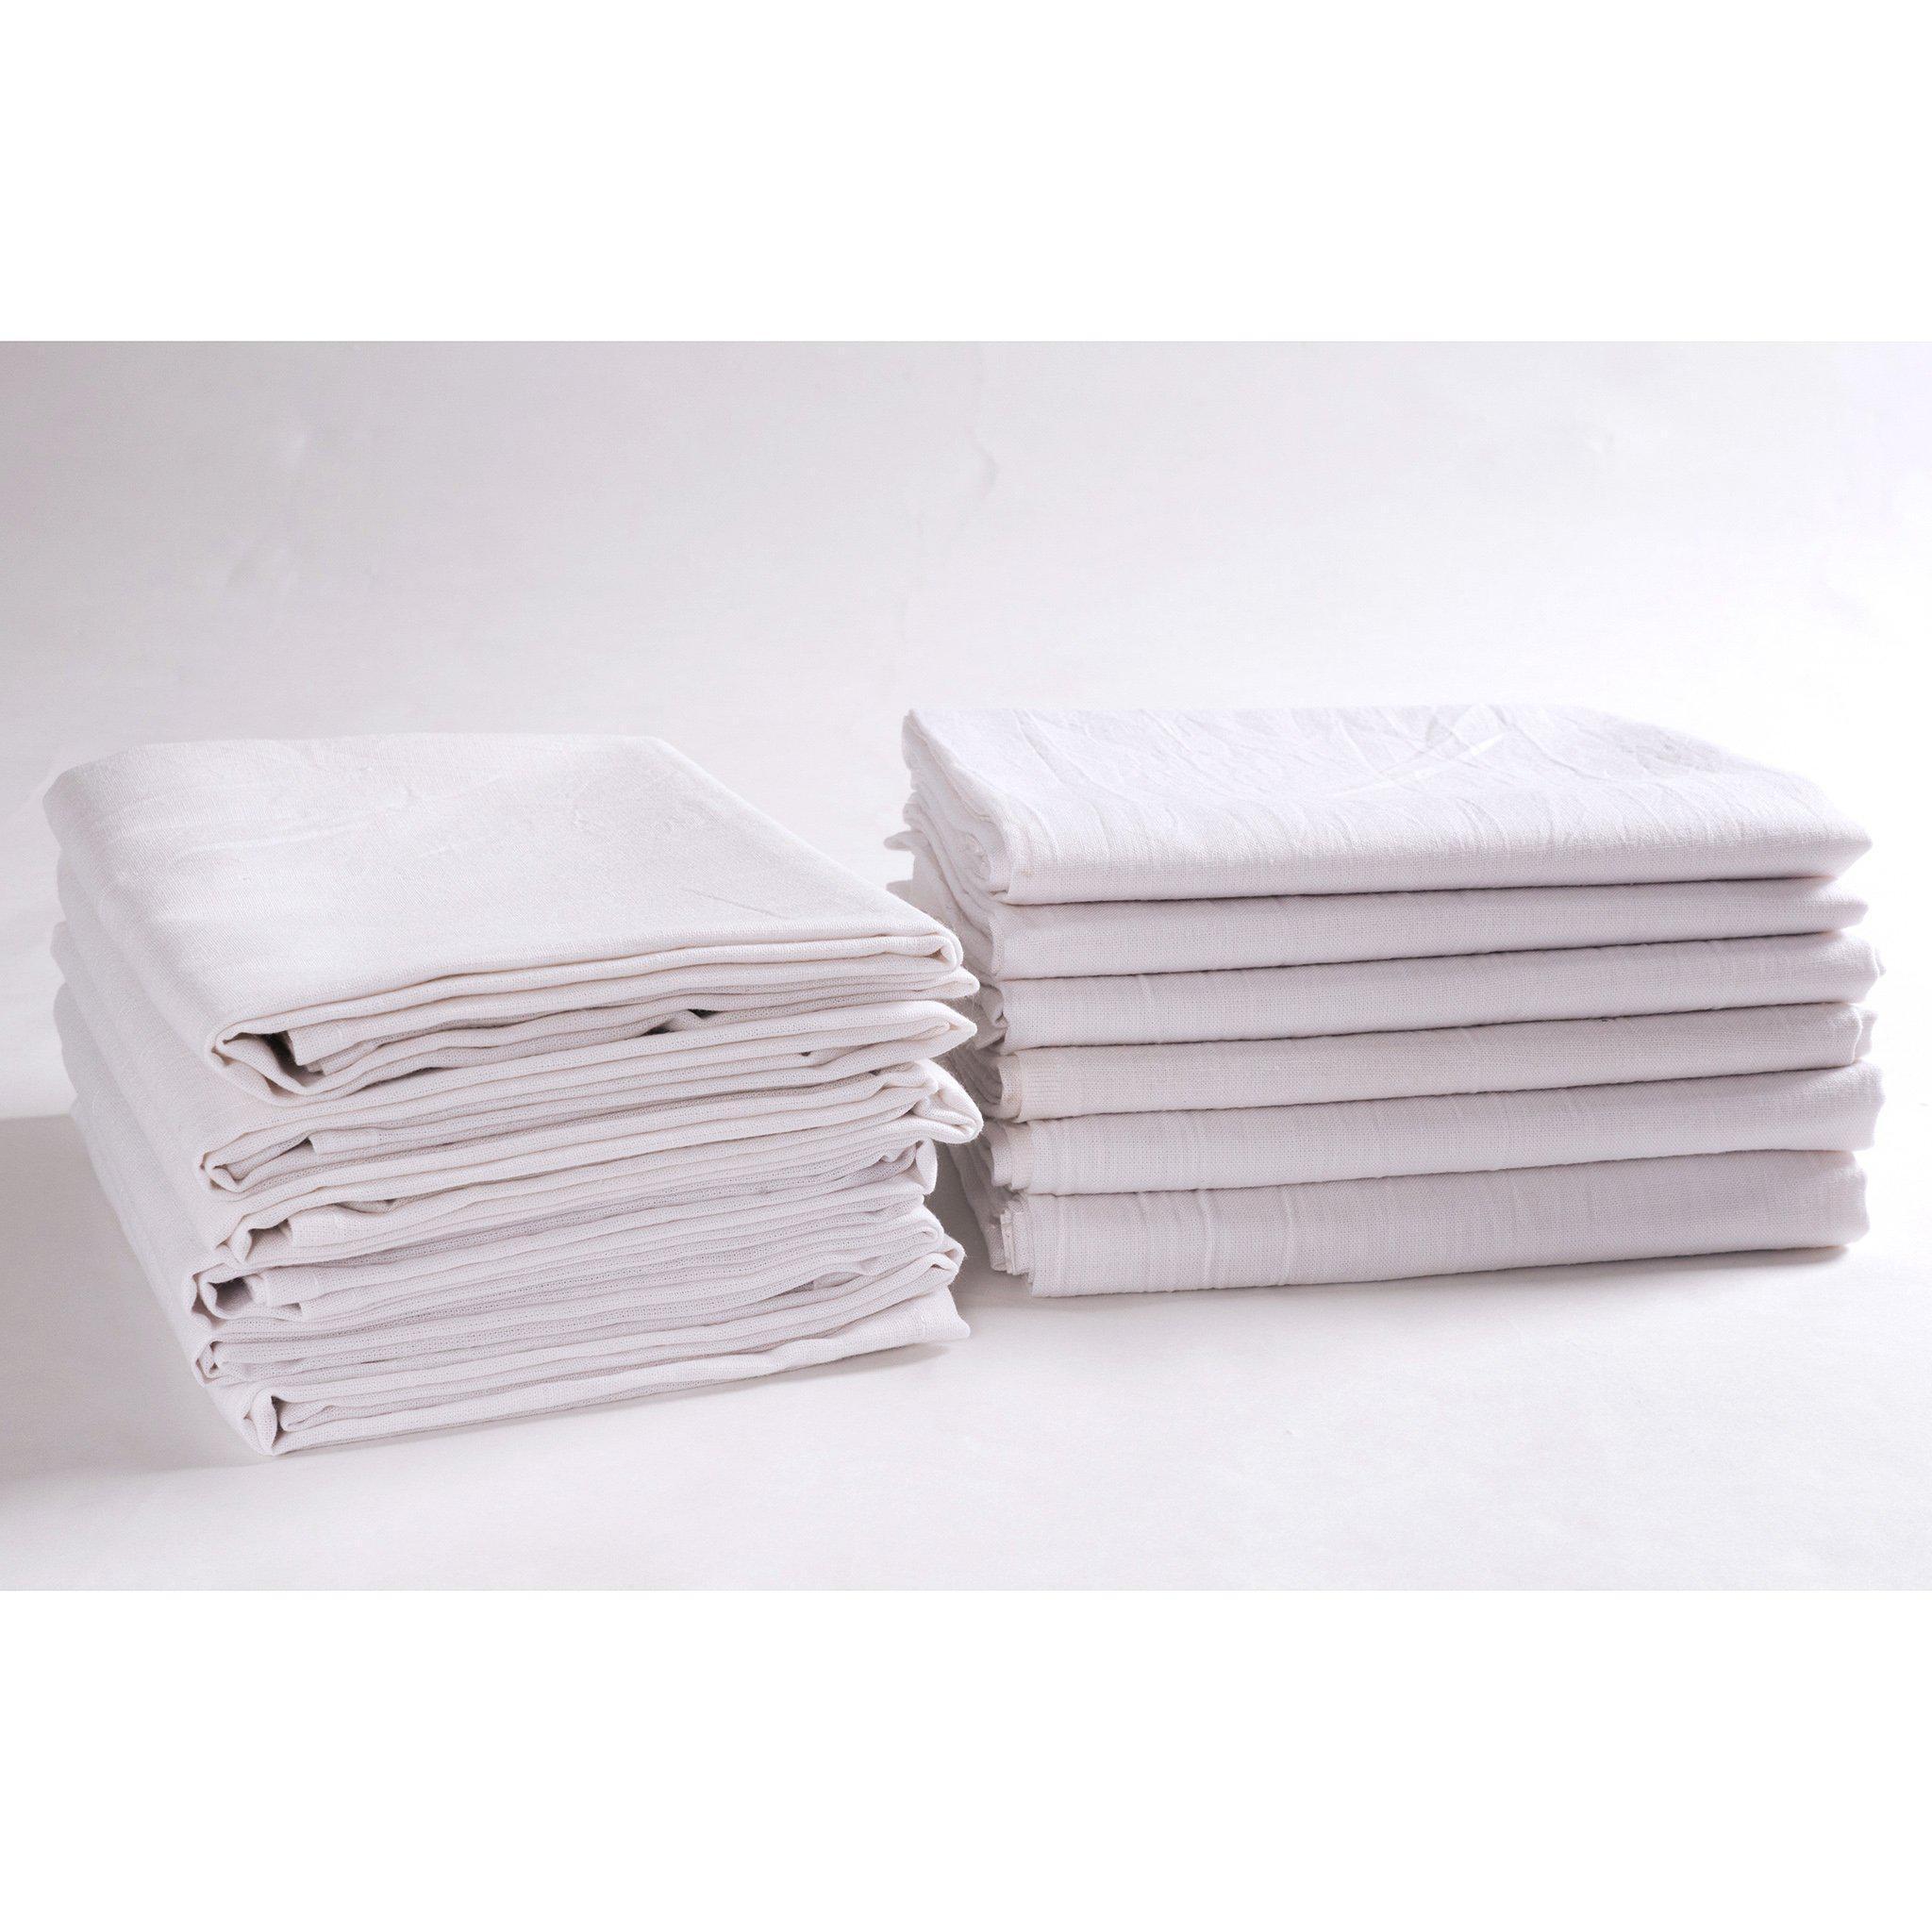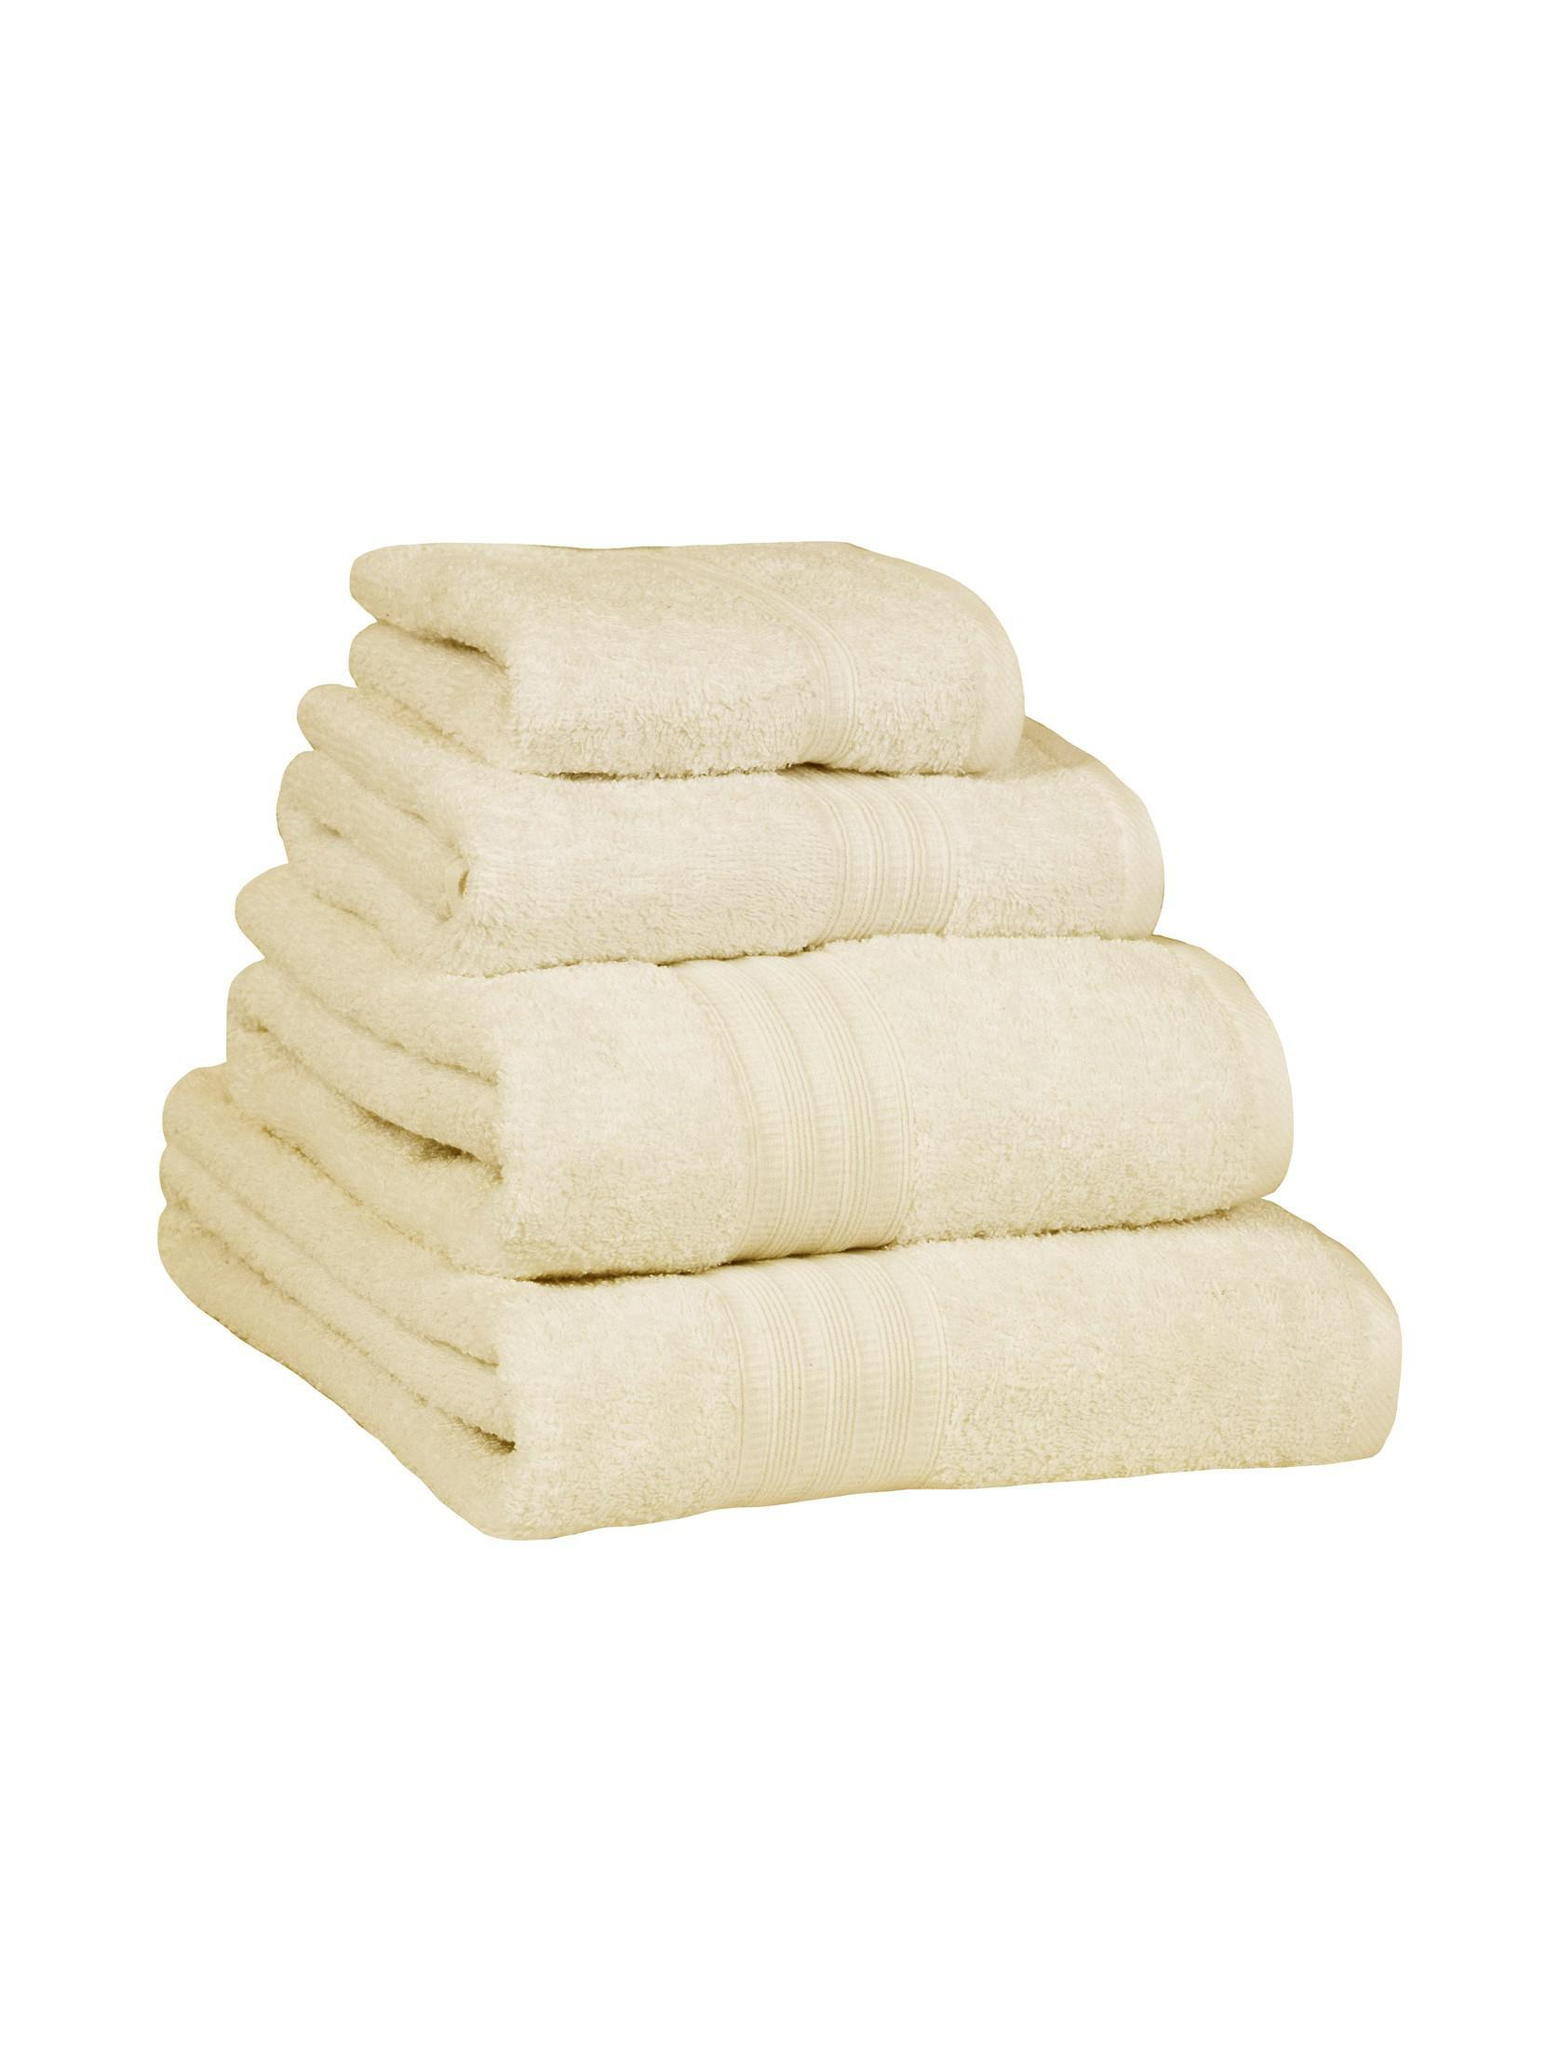The first image is the image on the left, the second image is the image on the right. Considering the images on both sides, is "At least one of the towels is brown." valid? Answer yes or no. No. The first image is the image on the left, the second image is the image on the right. For the images shown, is this caption "There are four towels in the right image." true? Answer yes or no. Yes. 